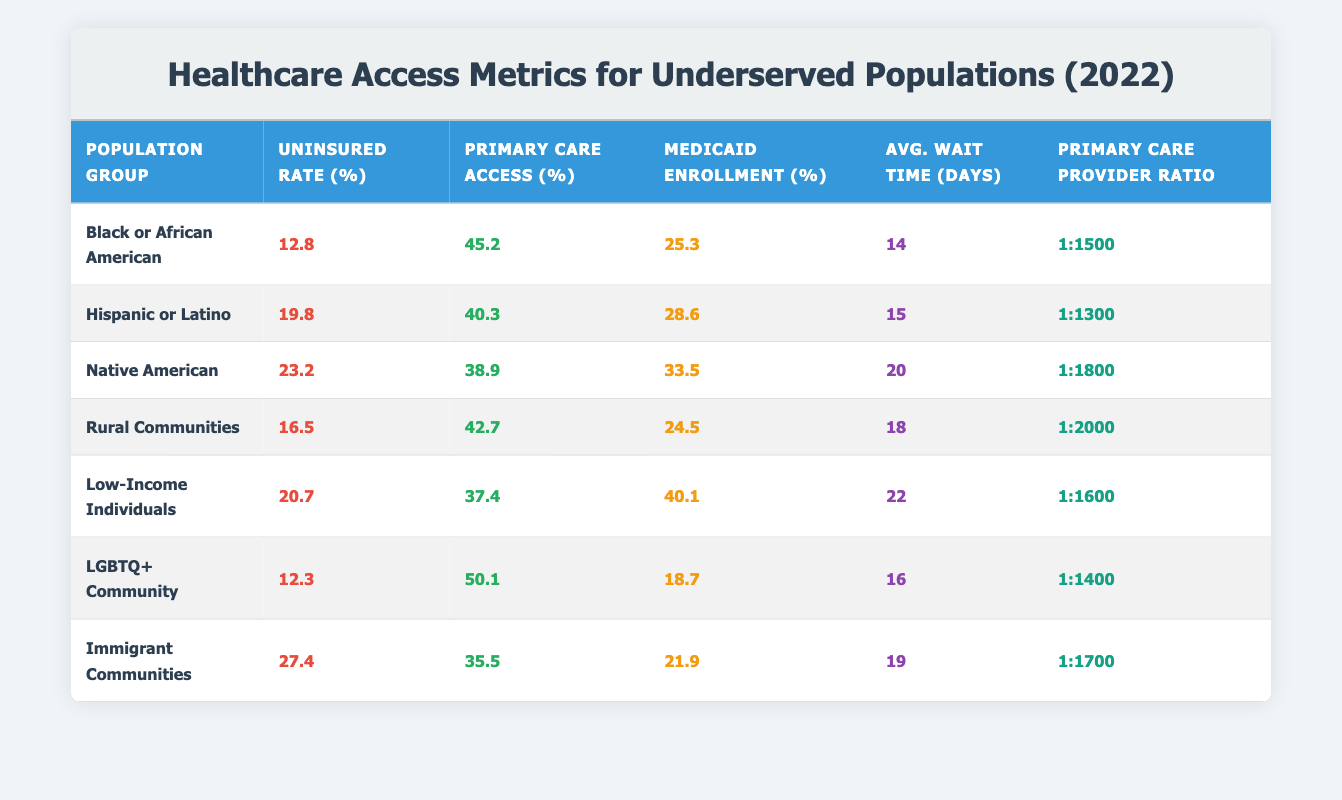What is the uninsured rate for the Native American population? According to the table, the uninsured rate for the Native American population is listed as 23.2%.
Answer: 23.2% Which population group has the highest rate of uninsured individuals? By examining the uninsured rates in the table, the Immigrant Communities show the highest rate at 27.4%.
Answer: Immigrant Communities What is the average wait time to appointments for Low-Income Individuals? The table shows that the average wait time to appointments for Low-Income Individuals is 22 days.
Answer: 22 days Calculate the primary care access percentage for the Hispanic or Latino population and the LGBTQ+ Community combined. The primary care access for Hispanic or Latino is 40.3% and for LGBTQ+ Community is 50.1%. Adding these gives us (40.3 + 50.1) = 90.4%.
Answer: 90.4% Is the Medicaid enrollment for the Rural Communities higher than the Medicaid enrollment for the Black or African American population? The Medicaid enrollment for Rural Communities is 24.5%, while for Black or African American it is 25.3%. Since 24.5% is less than 25.3%, the statement is false.
Answer: No Which population group has the lowest primary care access? Looking through the table, the group with the lowest primary care access is Low-Income Individuals at 37.4%.
Answer: Low-Income Individuals If you compare the average wait times for Native American and Rural Communities populations, which is longer? The average wait time for Native American is 20 days and for Rural Communities is 18 days. Since 20 is greater than 18, Native American has the longer wait time.
Answer: Native American What is the ratio of primary care providers to patients in the LGBTQ+ Community? The table indicates that the primary care provider ratio for the LGBTQ+ Community is 1:1400, meaning there is one provider for every 1400 individuals.
Answer: 1:1400 Identify the population group with the highest Medicaid enrollment rate. The table shows that Low-Income Individuals have the highest Medicaid enrollment rate at 40.1%.
Answer: Low-Income Individuals 